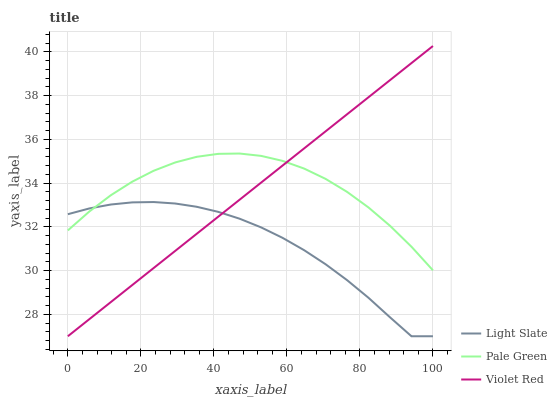Does Light Slate have the minimum area under the curve?
Answer yes or no. Yes. Does Pale Green have the maximum area under the curve?
Answer yes or no. Yes. Does Violet Red have the minimum area under the curve?
Answer yes or no. No. Does Violet Red have the maximum area under the curve?
Answer yes or no. No. Is Violet Red the smoothest?
Answer yes or no. Yes. Is Light Slate the roughest?
Answer yes or no. Yes. Is Pale Green the smoothest?
Answer yes or no. No. Is Pale Green the roughest?
Answer yes or no. No. Does Light Slate have the lowest value?
Answer yes or no. Yes. Does Pale Green have the lowest value?
Answer yes or no. No. Does Violet Red have the highest value?
Answer yes or no. Yes. Does Pale Green have the highest value?
Answer yes or no. No. Does Violet Red intersect Light Slate?
Answer yes or no. Yes. Is Violet Red less than Light Slate?
Answer yes or no. No. Is Violet Red greater than Light Slate?
Answer yes or no. No. 